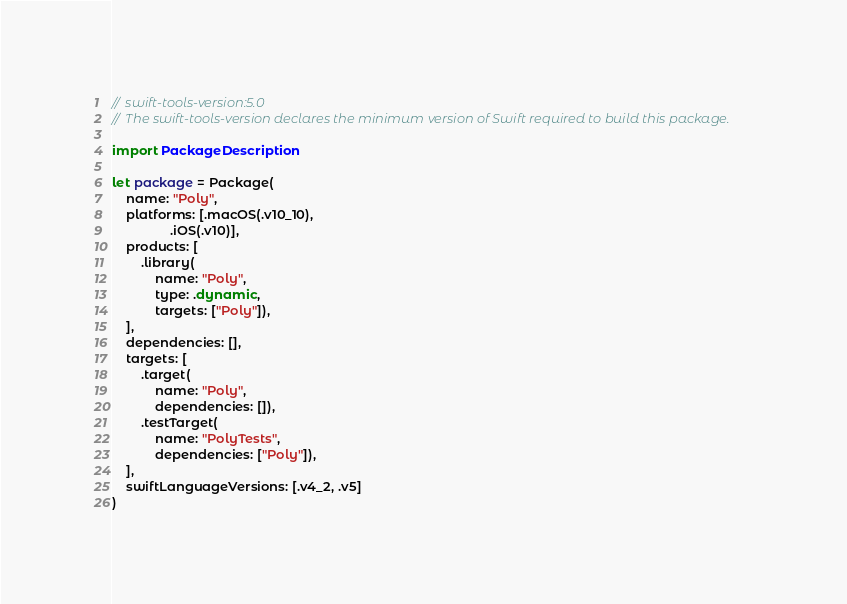<code> <loc_0><loc_0><loc_500><loc_500><_Swift_>// swift-tools-version:5.0
// The swift-tools-version declares the minimum version of Swift required to build this package.

import PackageDescription

let package = Package(
    name: "Poly",
    platforms: [.macOS(.v10_10),
                .iOS(.v10)],
    products: [
        .library(
            name: "Poly",
            type: .dynamic,
            targets: ["Poly"]),
    ],
    dependencies: [],
    targets: [
        .target(
            name: "Poly",
            dependencies: []),
        .testTarget(
            name: "PolyTests",
            dependencies: ["Poly"]),
    ],
    swiftLanguageVersions: [.v4_2, .v5]
)
</code> 